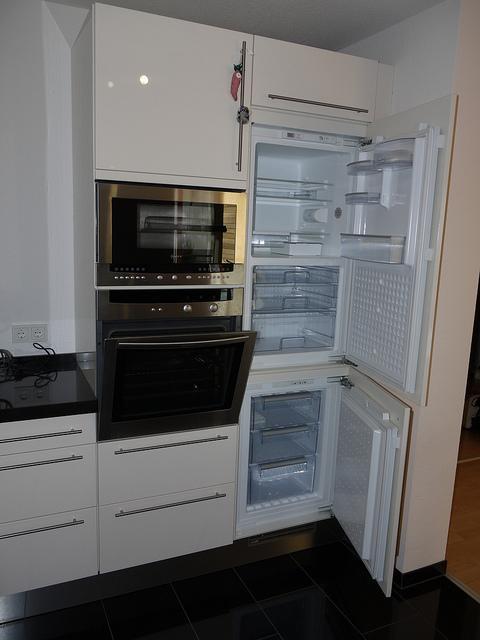How many appliances belong in the kitchen?
Give a very brief answer. 3. How many ovens are in this kitchen?
Give a very brief answer. 1. How many microwaves are there?
Give a very brief answer. 1. 